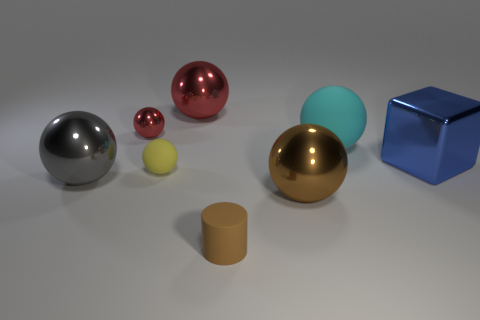Subtract 1 balls. How many balls are left? 5 Subtract all gray balls. How many balls are left? 5 Subtract all small shiny spheres. How many spheres are left? 5 Subtract all cyan spheres. Subtract all gray cylinders. How many spheres are left? 5 Add 1 big metallic cylinders. How many objects exist? 9 Subtract all cylinders. How many objects are left? 7 Add 2 cyan balls. How many cyan balls are left? 3 Add 4 red balls. How many red balls exist? 6 Subtract 0 red cylinders. How many objects are left? 8 Subtract all large purple matte spheres. Subtract all yellow objects. How many objects are left? 7 